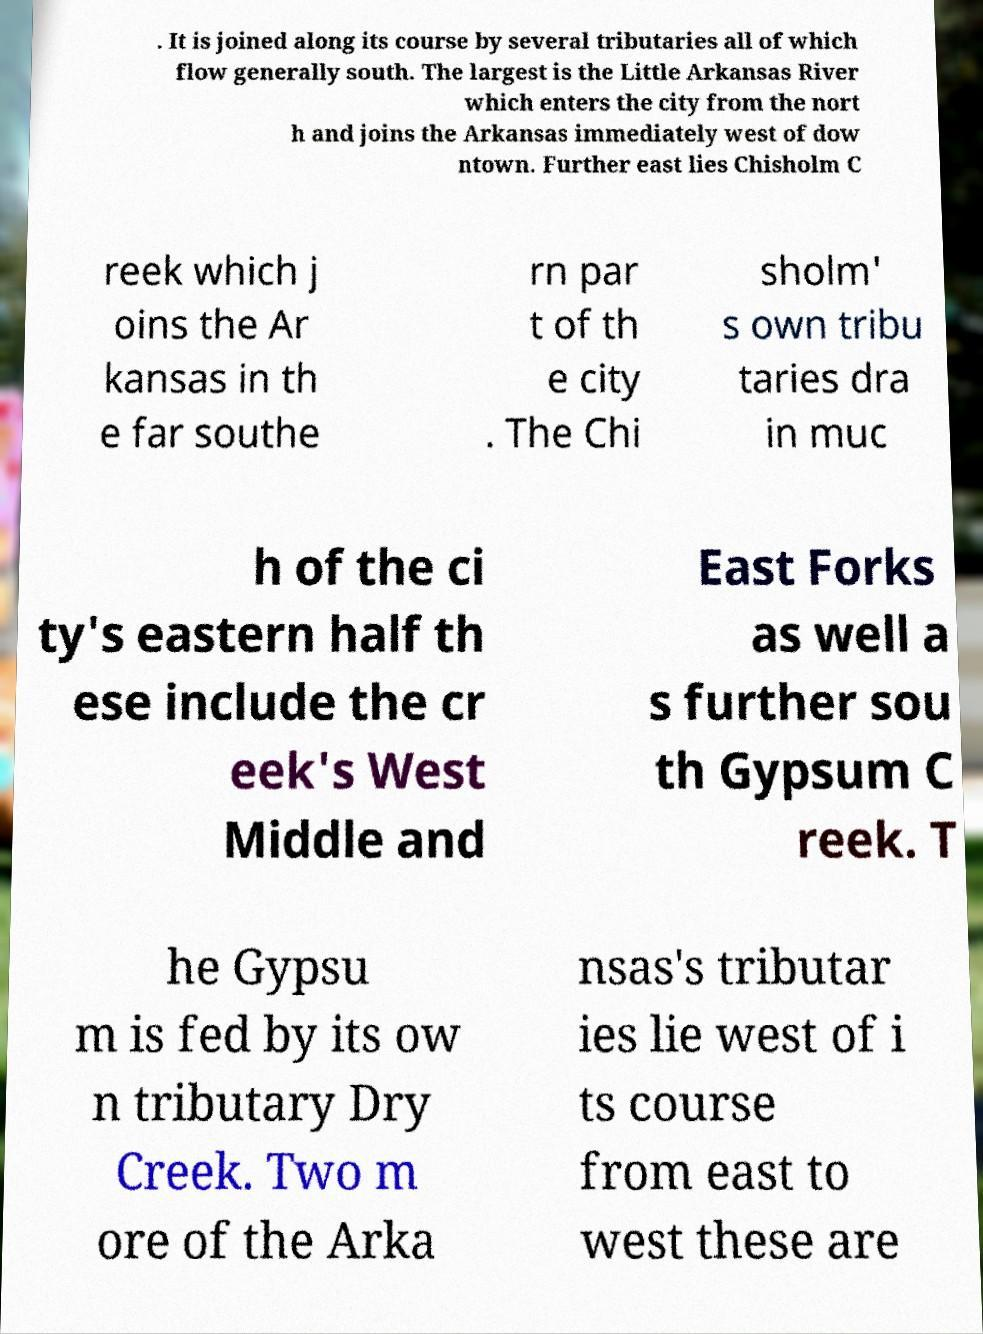Could you assist in decoding the text presented in this image and type it out clearly? . It is joined along its course by several tributaries all of which flow generally south. The largest is the Little Arkansas River which enters the city from the nort h and joins the Arkansas immediately west of dow ntown. Further east lies Chisholm C reek which j oins the Ar kansas in th e far southe rn par t of th e city . The Chi sholm' s own tribu taries dra in muc h of the ci ty's eastern half th ese include the cr eek's West Middle and East Forks as well a s further sou th Gypsum C reek. T he Gypsu m is fed by its ow n tributary Dry Creek. Two m ore of the Arka nsas's tributar ies lie west of i ts course from east to west these are 